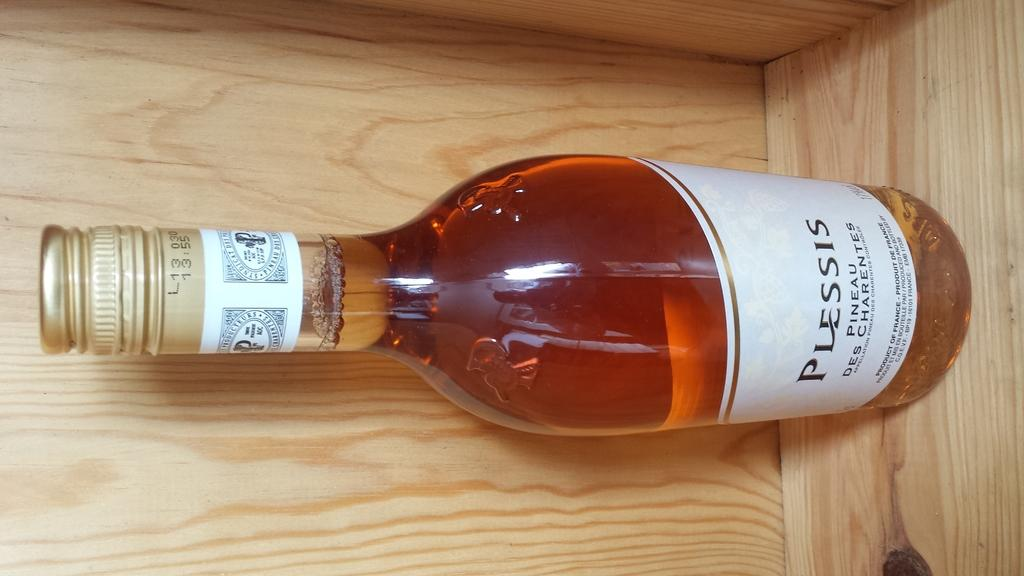Provide a one-sentence caption for the provided image. The brand name of a wine bottle is Plessis. 